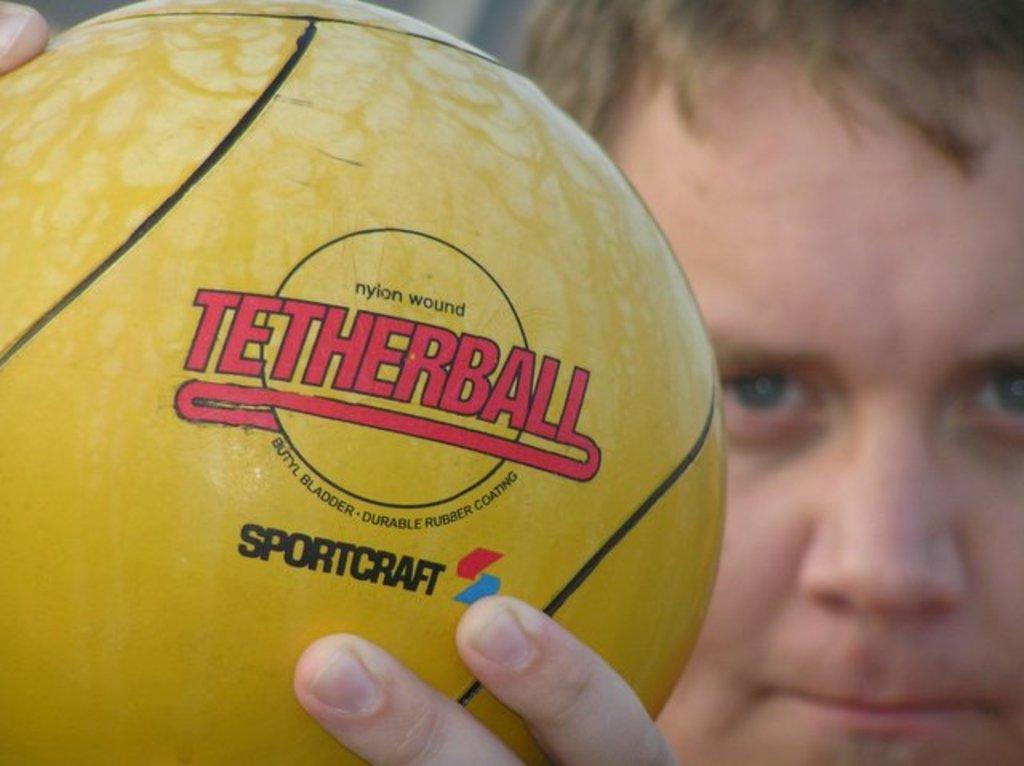Provide a one-sentence caption for the provided image. A boy holds a yellow tetherball manufactured by Sportcraft. 